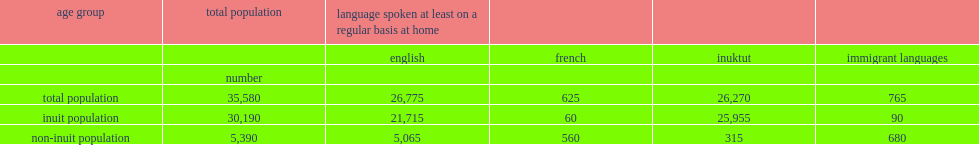In 2016, what was the number of inuit reported speaking french at least on a regular basis at home? 60.0. How many inuit spoke an immigrant language at home? 90.0. 